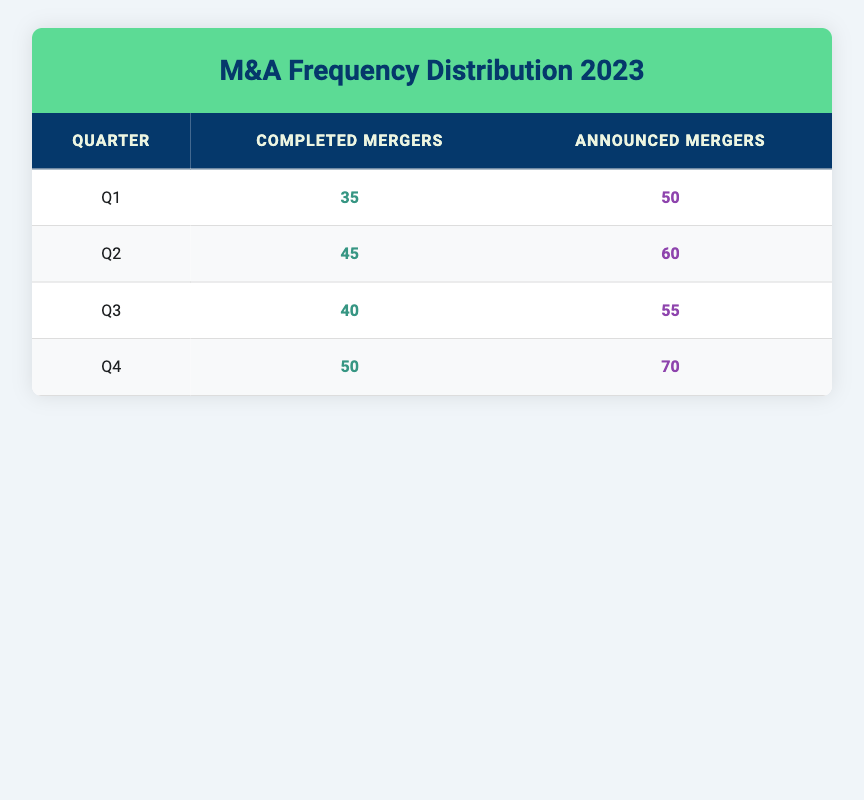What was the total number of completed mergers in Q2? To find the total number of completed mergers in Q2, we look directly at the corresponding value in the table, which shows 45 completed mergers for that quarter.
Answer: 45 How many announced mergers were there in Q3? The value for announced mergers in Q3 can be found directly in the table, which indicates there were 55 announced mergers in that quarter.
Answer: 55 What is the difference between the number of completed mergers in Q4 and Q1? First, we find the values for completed mergers in Q4 and Q1 from the table, which are 50 and 35, respectively. Next, we subtract Q1's value from Q4's: 50 - 35 = 15.
Answer: 15 How many more announced mergers were there in Q4 compared to Q2? From the table, Q4 has 70 announced mergers and Q2 has 60. We subtract Q2's value from Q4's: 70 - 60 = 10.
Answer: 10 Is it true that the number of completed mergers increased in every quarter of 2023? We examine the completed mergers across the quarters: Q1 has 35, Q2 has 45, Q3 has 40, and Q4 has 50. The numbers did not increase from Q2 to Q3 (from 45 to 40), so the statement is false.
Answer: No What was the average number of announced mergers for all quarters in 2023? We first sum the announced mergers for all quarters: 50 (Q1) + 60 (Q2) + 55 (Q3) + 70 (Q4) = 235. Then, we divide this sum by the number of quarters (4): 235 / 4 = 58.75.
Answer: 58.75 Which quarter had the highest number of completed mergers? We check the completed mergers for each quarter: Q1 has 35, Q2 has 45, Q3 has 40, and Q4 has 50. Q4 has the highest value of 50 completed mergers.
Answer: Q4 What is the ratio of completed mergers to announced mergers in Q1? We take the values from Q1: completed mergers are 35 and announced mergers are 50. The ratio is 35:50. To simplify, we can divide both by 5, giving us 7:10.
Answer: 7:10 Was the total number of completed mergers greater than the total number of announced mergers for all quarters combined? First, we sum the completed mergers: 35 + 45 + 40 + 50 = 170. Then we sum the announced mergers: 50 + 60 + 55 + 70 = 235. Since 170 is less than 235, the statement is false.
Answer: No 